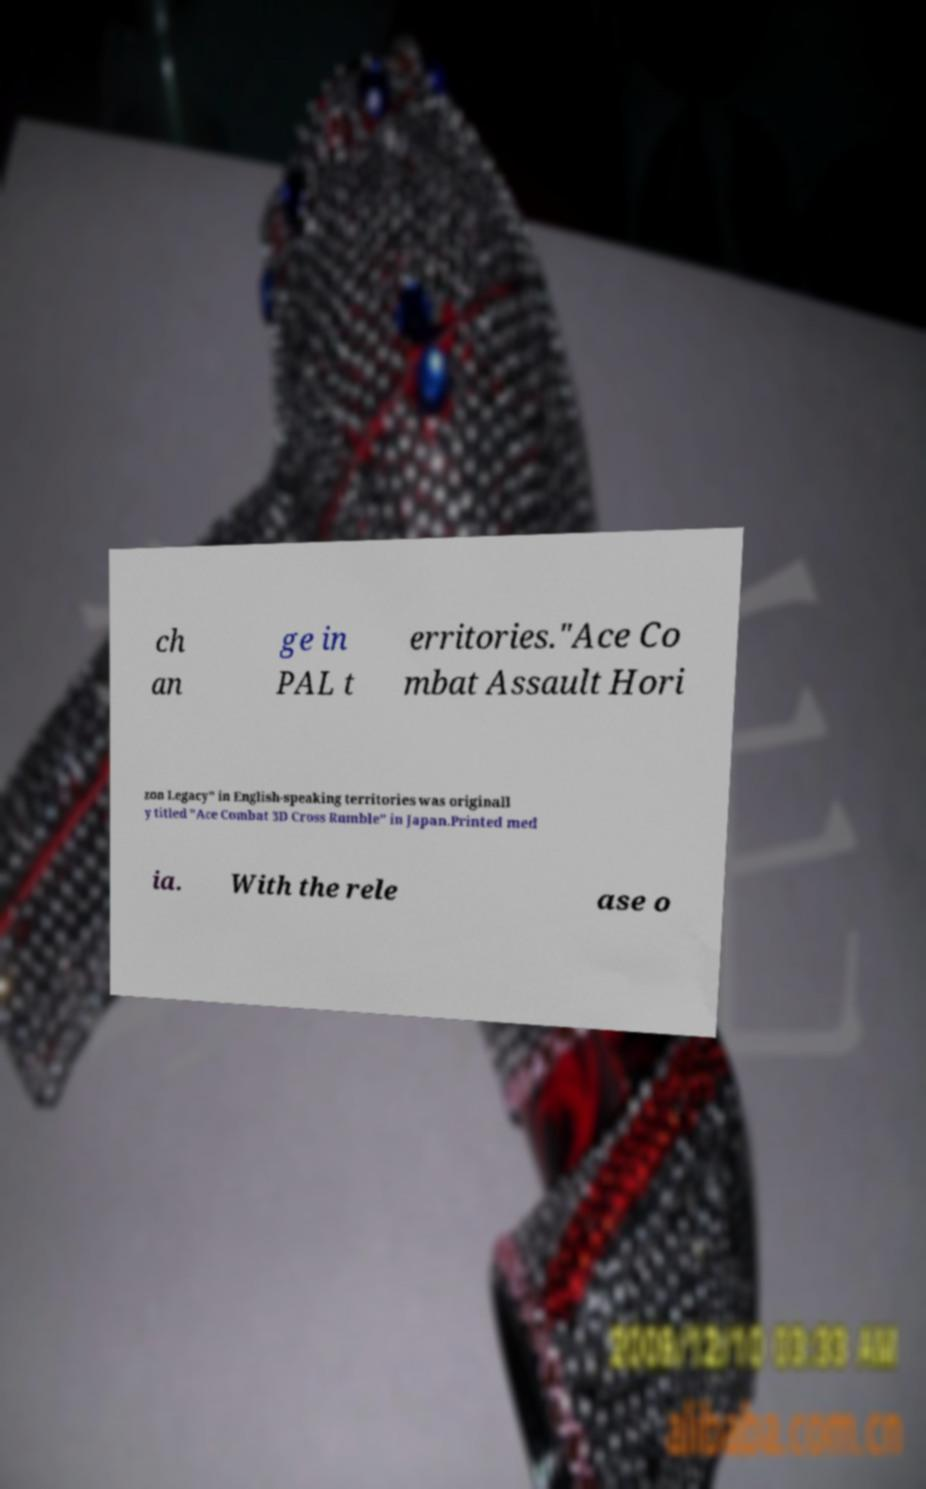I need the written content from this picture converted into text. Can you do that? ch an ge in PAL t erritories."Ace Co mbat Assault Hori zon Legacy" in English-speaking territories was originall y titled "Ace Combat 3D Cross Rumble" in Japan.Printed med ia. With the rele ase o 